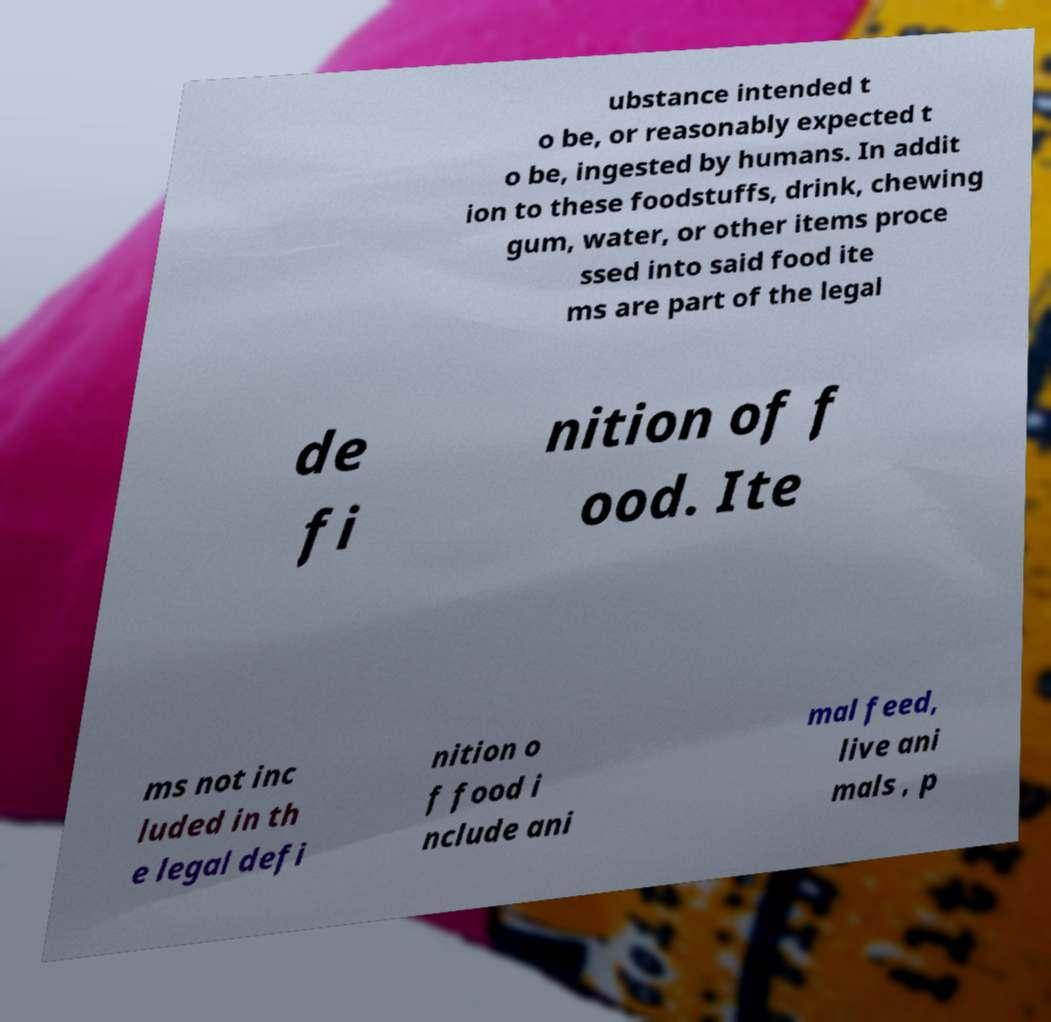Can you read and provide the text displayed in the image?This photo seems to have some interesting text. Can you extract and type it out for me? ubstance intended t o be, or reasonably expected t o be, ingested by humans. In addit ion to these foodstuffs, drink, chewing gum, water, or other items proce ssed into said food ite ms are part of the legal de fi nition of f ood. Ite ms not inc luded in th e legal defi nition o f food i nclude ani mal feed, live ani mals , p 